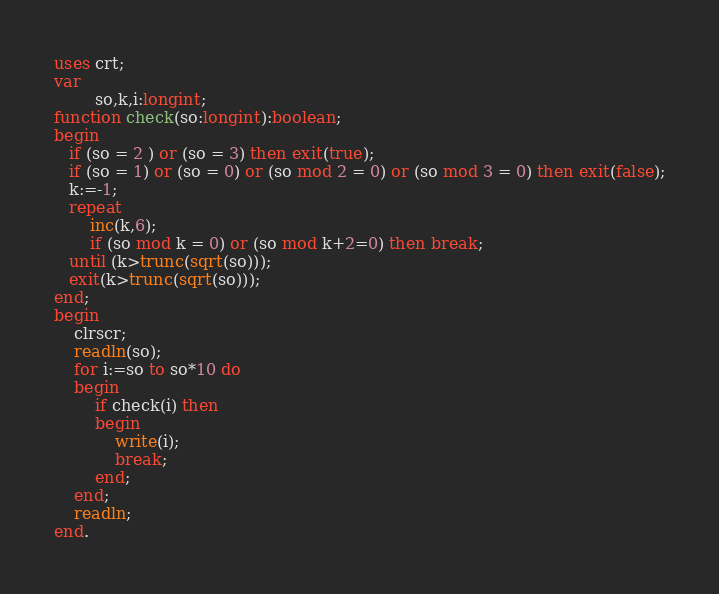Convert code to text. <code><loc_0><loc_0><loc_500><loc_500><_Pascal_>uses crt;
var
        so,k,i:longint;
function check(so:longint):boolean;
begin
   if (so = 2 ) or (so = 3) then exit(true);
   if (so = 1) or (so = 0) or (so mod 2 = 0) or (so mod 3 = 0) then exit(false);
   k:=-1;
   repeat
       inc(k,6);
       if (so mod k = 0) or (so mod k+2=0) then break;
   until (k>trunc(sqrt(so)));
   exit(k>trunc(sqrt(so)));
end;
begin
    clrscr;
    readln(so);
    for i:=so to so*10 do
    begin
        if check(i) then
        begin
            write(i);
            break;
        end;
    end;
    readln;
end.

</code> 